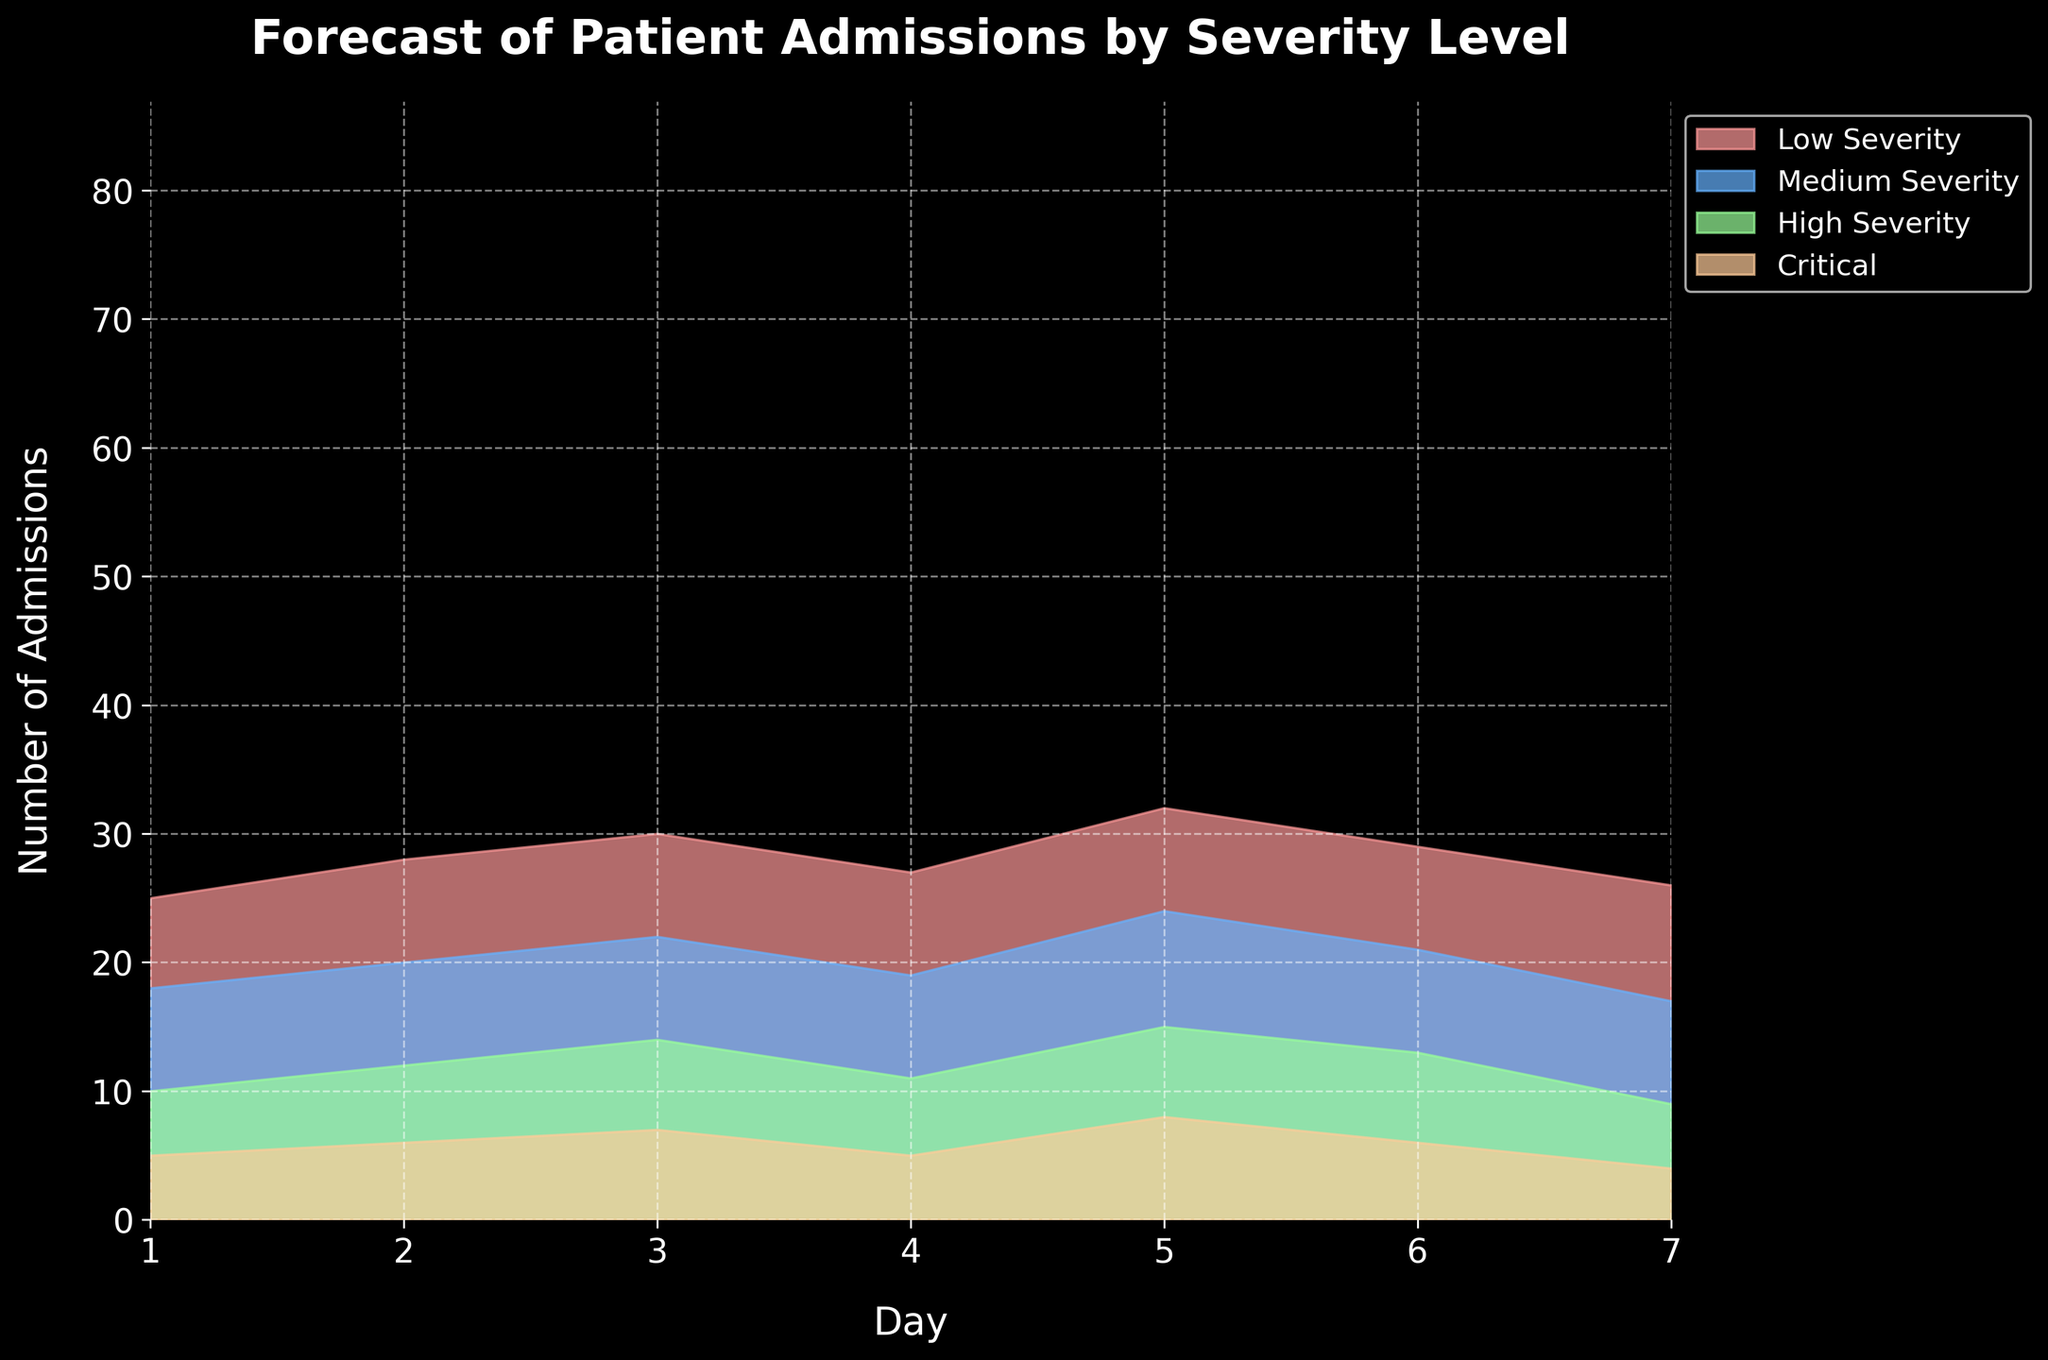What is the title of the chart? The title is usually located at the top of the chart and summarizes what the chart is about. Here, it would be about the forecast of patient admissions by severity level.
Answer: Forecast of Patient Admissions by Severity Level How many days does the forecast cover? The X-axis of the chart represents the number of days, which can be identified by counting the labels or ticks on the X-axis.
Answer: 7 days What severity level has the highest admission rate on Day 5? By looking at the different colored layers representing each severity level on Day 5, the layer that reaches the highest point indicates the highest admission rate for that day.
Answer: Low Severity What is the total number of admissions expected on Day 3? Sum the values for each severity level on Day 3: 30 (Low) + 22 (Medium) + 14 (High) + 7 (Critical) = 73.
Answer: 73 Which severity level shows the most variation over the 7 days? Look at the layers representing each severity level and assess which layer varies the most in height from day to day. The more change, the more variation.
Answer: Low Severity How does the number of Critical admissions on Day 1 compare to Day 7? Check the vertical extent of the Critical severity layer on Day 1 and Day 7, then compare the values directly.
Answer: The number of Critical admissions on Day 1 is higher than on Day 7 By how much do Medium Severity admissions on Day 5 exceed those on Day 4? Subtract the Medium Severity admissions on Day 4 from those on Day 5: 24 (Day 5) - 19 (Day 4) = 5.
Answer: 5 Which day has the overall highest number of admissions? Sum the number of admissions for all severity levels for each day and identify the day with the highest total.
Answer: Day 5 On which day does High Severity have its lowest forecasted admissions? Compare the vertical height of the High Severity layers across all days and find the day with the smallest value.
Answer: Day 7 Do Critical admissions ever exceed 10 patients? Check the values of the Critical layer for each day to see if any exceed 10.
Answer: No 